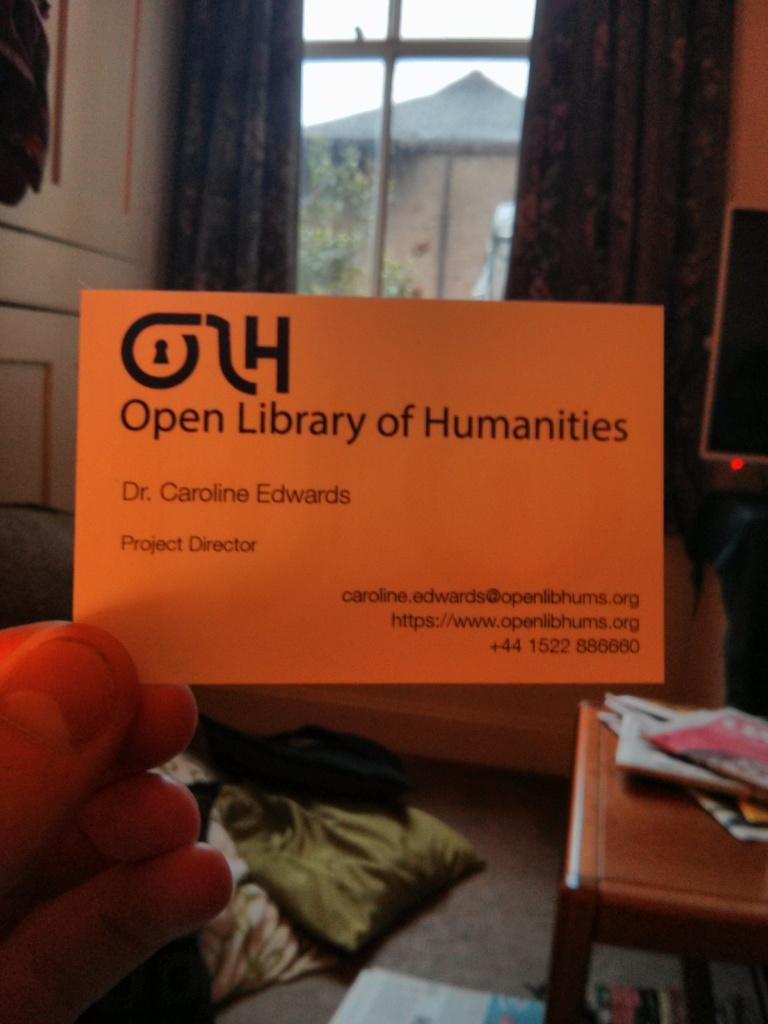<image>
Present a compact description of the photo's key features. An orange card with Open Library of Humanities written on it 